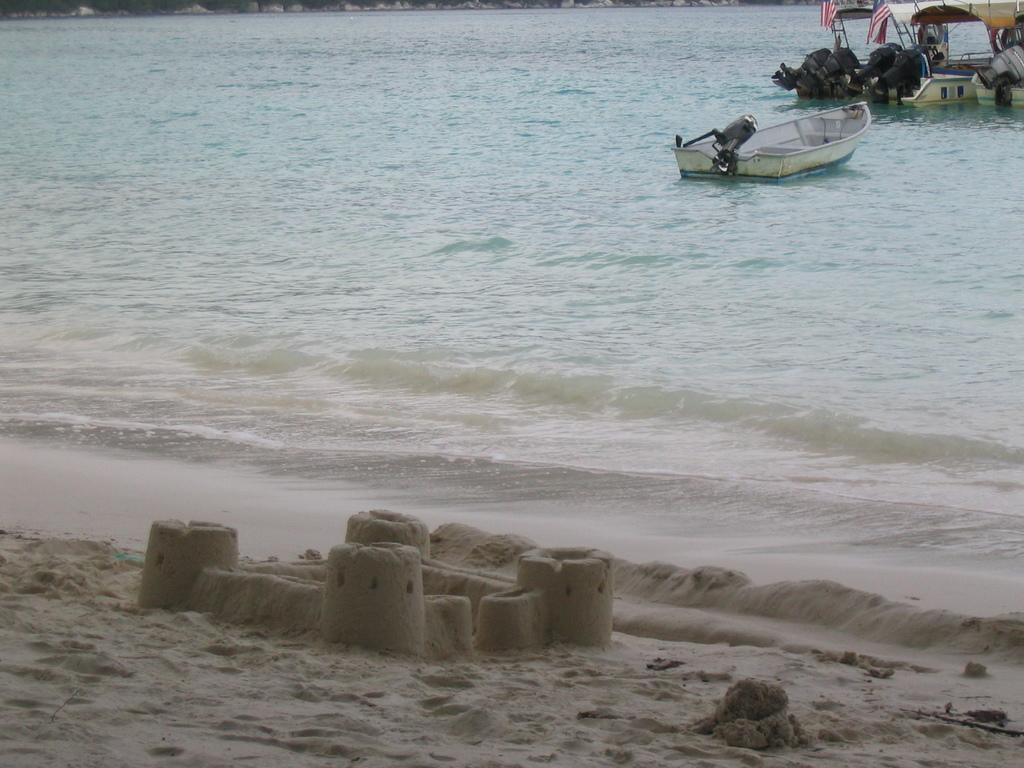What is the main subject of the image? The main subject of the image is sand carving. What is being depicted in the sand carving? The sand carving features boats. What are the boats equipped with? The boats have motors and flags. What type of collar is being used to control the boats in the image? There is no collar present in the image, as the boats are depicted in a sand carving and not in a real-life scenario. 